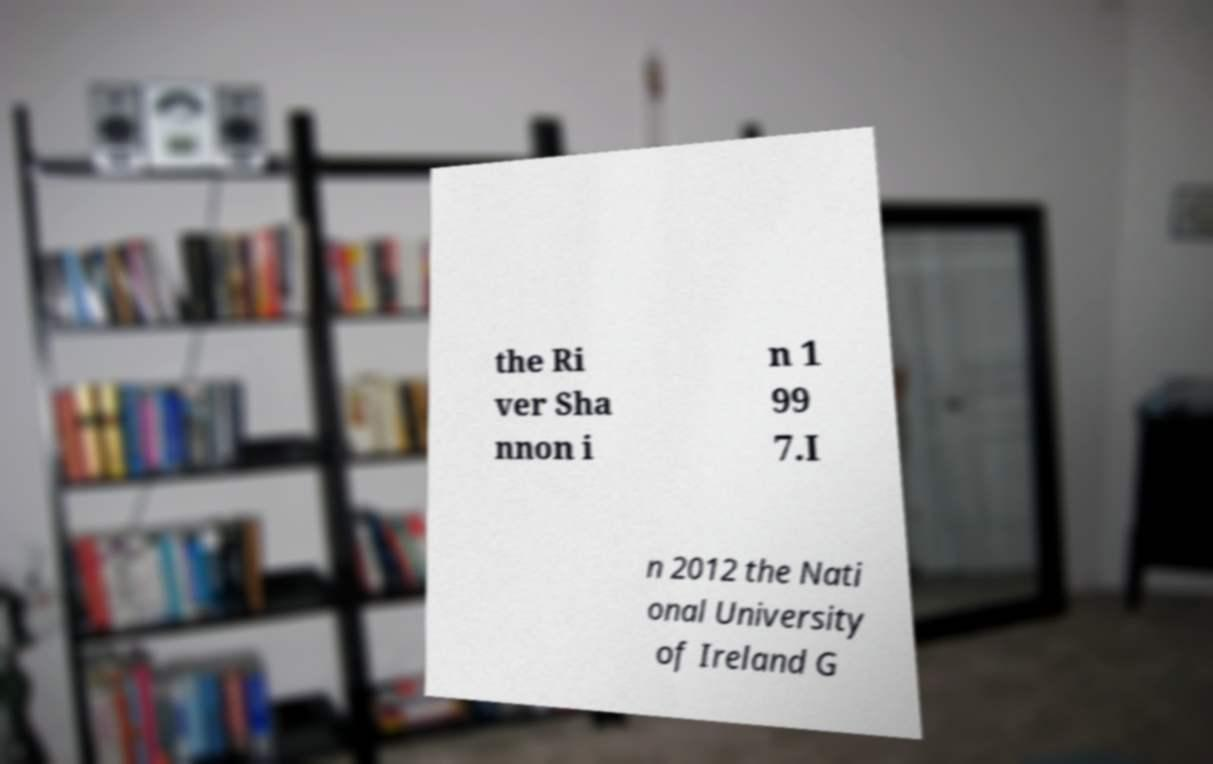Can you read and provide the text displayed in the image?This photo seems to have some interesting text. Can you extract and type it out for me? the Ri ver Sha nnon i n 1 99 7.I n 2012 the Nati onal University of Ireland G 